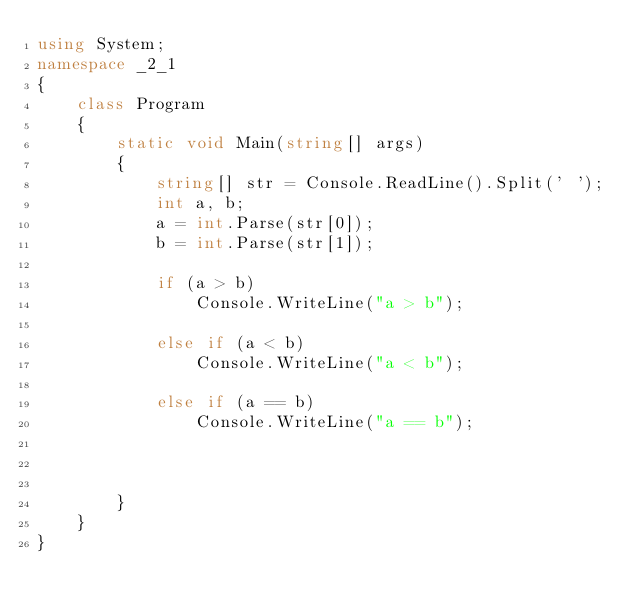Convert code to text. <code><loc_0><loc_0><loc_500><loc_500><_C#_>using System;
namespace _2_1
{
    class Program
    {
        static void Main(string[] args)
        {
            string[] str = Console.ReadLine().Split(' ');
            int a, b;
            a = int.Parse(str[0]);
            b = int.Parse(str[1]);

            if (a > b)
                Console.WriteLine("a > b");

            else if (a < b)
                Console.WriteLine("a < b");

            else if (a == b)
                Console.WriteLine("a == b");



        }
    }
}

</code> 